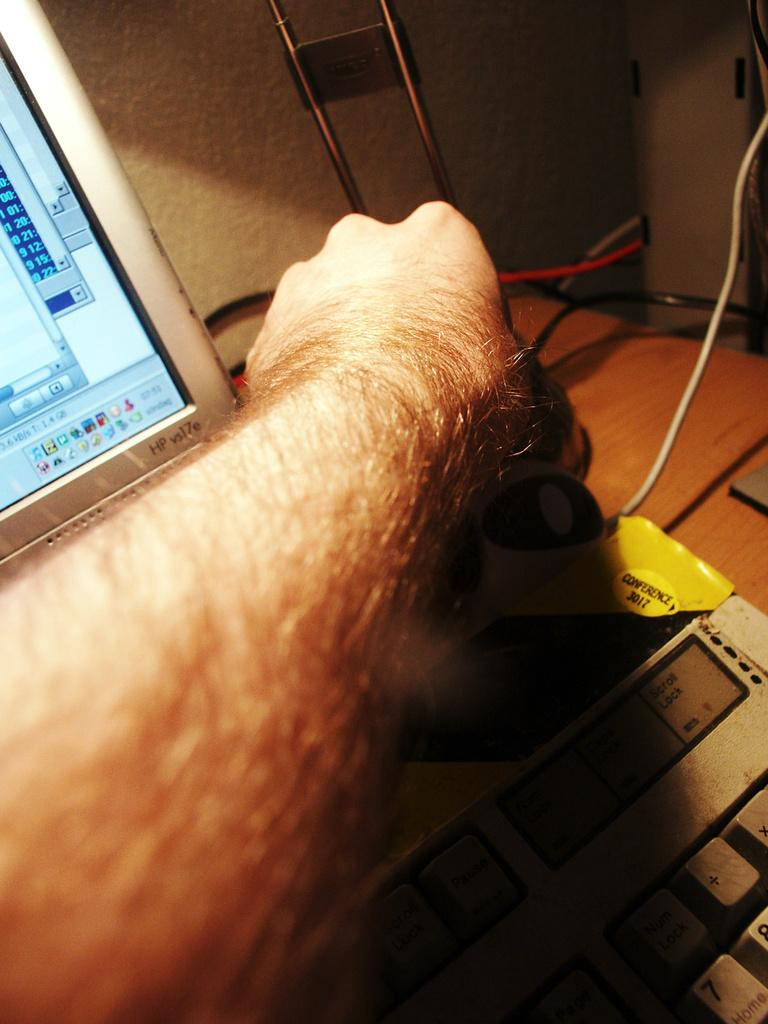<image>
Render a clear and concise summary of the photo. A man is using a HP vs17e laptop 